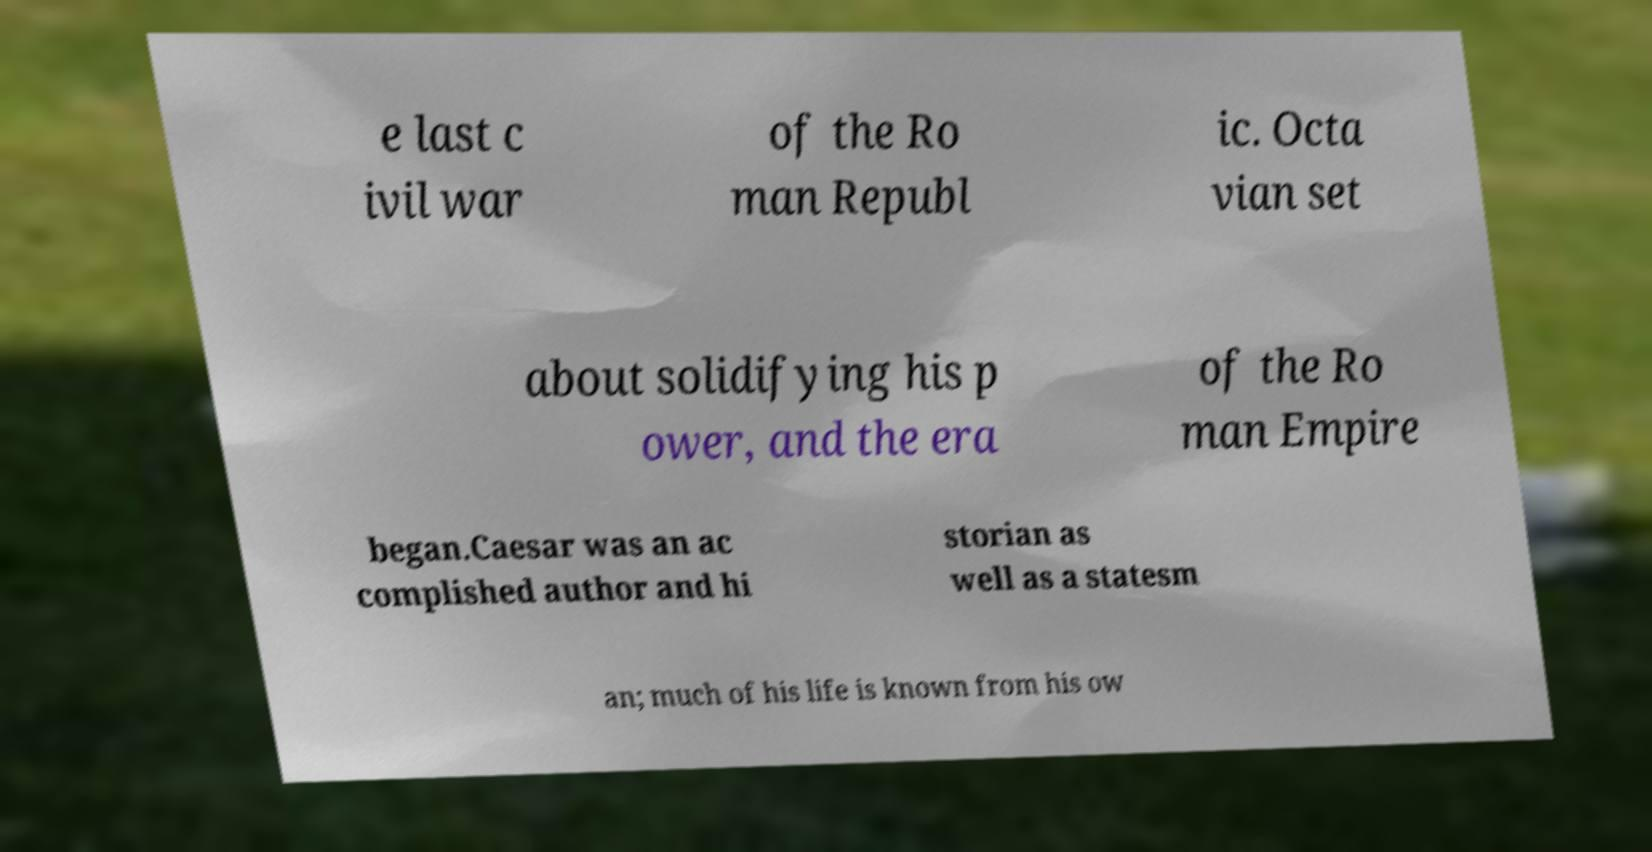Can you read and provide the text displayed in the image?This photo seems to have some interesting text. Can you extract and type it out for me? e last c ivil war of the Ro man Republ ic. Octa vian set about solidifying his p ower, and the era of the Ro man Empire began.Caesar was an ac complished author and hi storian as well as a statesm an; much of his life is known from his ow 